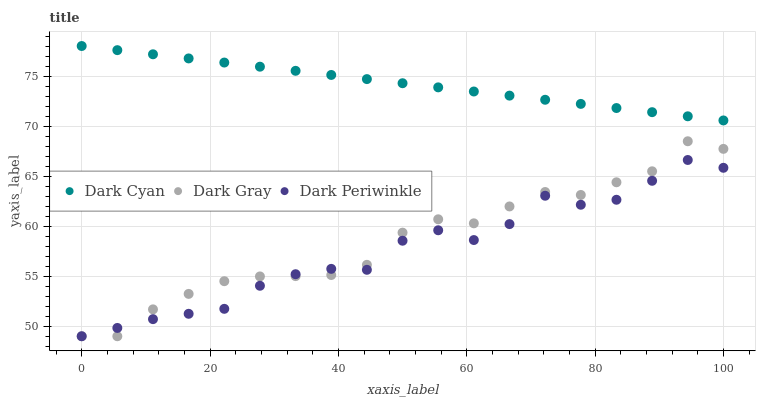Does Dark Periwinkle have the minimum area under the curve?
Answer yes or no. Yes. Does Dark Cyan have the maximum area under the curve?
Answer yes or no. Yes. Does Dark Gray have the minimum area under the curve?
Answer yes or no. No. Does Dark Gray have the maximum area under the curve?
Answer yes or no. No. Is Dark Cyan the smoothest?
Answer yes or no. Yes. Is Dark Periwinkle the roughest?
Answer yes or no. Yes. Is Dark Gray the smoothest?
Answer yes or no. No. Is Dark Gray the roughest?
Answer yes or no. No. Does Dark Gray have the lowest value?
Answer yes or no. Yes. Does Dark Cyan have the highest value?
Answer yes or no. Yes. Does Dark Gray have the highest value?
Answer yes or no. No. Is Dark Gray less than Dark Cyan?
Answer yes or no. Yes. Is Dark Cyan greater than Dark Periwinkle?
Answer yes or no. Yes. Does Dark Gray intersect Dark Periwinkle?
Answer yes or no. Yes. Is Dark Gray less than Dark Periwinkle?
Answer yes or no. No. Is Dark Gray greater than Dark Periwinkle?
Answer yes or no. No. Does Dark Gray intersect Dark Cyan?
Answer yes or no. No. 